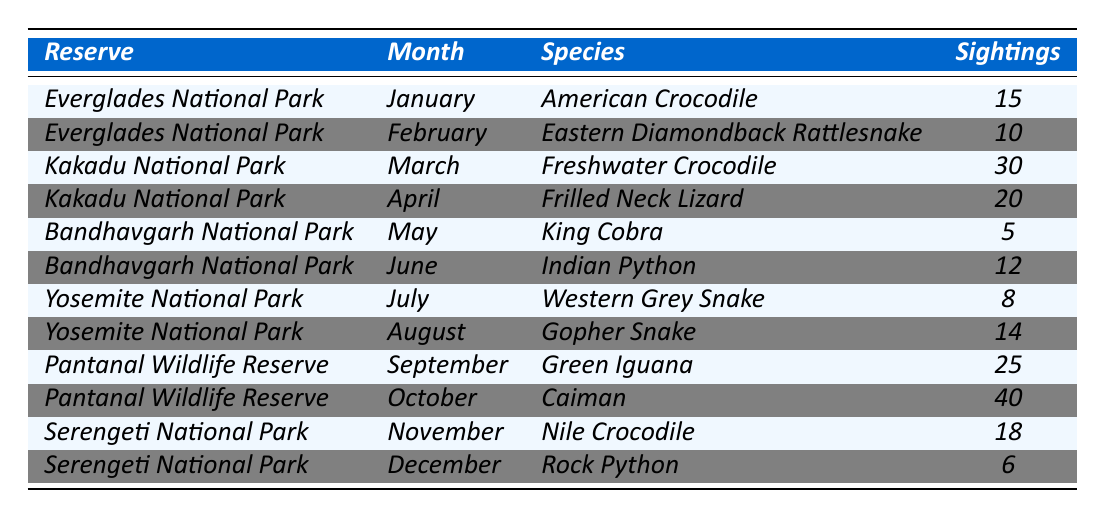What species was sighted the most in Pantanal Wildlife Reserve? The table shows that the Caiman had the highest number of sightings in Pantanal Wildlife Reserve with 40 sightings in October.
Answer: Caiman In which month was the American Crocodile sighted? The table indicates that the American Crocodile was sighted in January, with a total of 15 sightings in Everglades National Park.
Answer: January How many species were sighted in Kakadu National Park? The table lists two sightings in Kakadu National Park: Freshwater Crocodile in March and Frilled Neck Lizard in April, which totals two species.
Answer: 2 Which species had the least sightings across all reserves? By checking the table, King Cobra in Bandhavgarh National Park had the least sightings with only 5 reported in May.
Answer: King Cobra What is the total number of sightings of reptiles in Yosemite National Park? The table shows that in Yosemite National Park, the Western Grey Snake had 8 sightings in July and the Gopher Snake had 14 sightings in August, totaling 22 sightings.
Answer: 22 Did any reserve report sightings in December? Yes, the table indicates that Serengeti National Park reported sightings of the Rock Python in December.
Answer: Yes What is the average number of sightings for reptiles in Everglades National Park? The table shows 2 entries for Everglades National Park: American Crocodile (15 sightings) and Eastern Diamondback Rattlesnake (10 sightings). The average is (15 + 10) / 2 = 12.5.
Answer: 12.5 Which month had the highest number of reptile sightings overall? The table shows that October had the highest number of sightings with 40 for Caiman in Pantanal Wildlife Reserve. Therefore, October is the month with the highest sightings.
Answer: October How many more sightings were there for the Caiman compared to the King Cobra? The table indicates 40 sightings for Caiman and 5 for King Cobra. The difference is 40 - 5 = 35 sightings more for Caiman.
Answer: 35 In which month did the Eastern Diamondback Rattlesnake appear, and how many sightings were reported? The table shows that the Eastern Diamondback Rattlesnake was sighted in February with a total of 10 sightings.
Answer: February, 10 sightings 